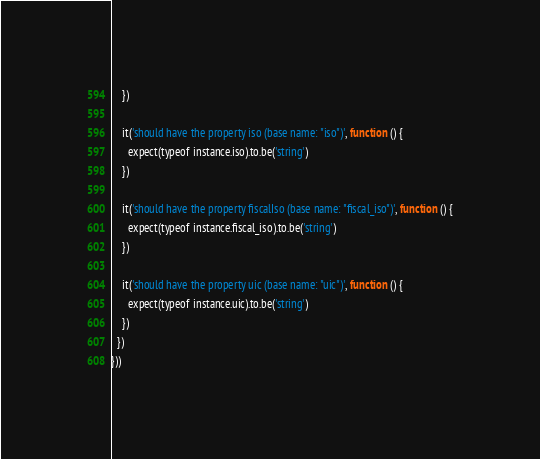Convert code to text. <code><loc_0><loc_0><loc_500><loc_500><_JavaScript_>    })

    it('should have the property iso (base name: "iso")', function () {
      expect(typeof instance.iso).to.be('string')
    })

    it('should have the property fiscalIso (base name: "fiscal_iso")', function () {
      expect(typeof instance.fiscal_iso).to.be('string')
    })

    it('should have the property uic (base name: "uic")', function () {
      expect(typeof instance.uic).to.be('string')
    })
  })
}))
</code> 